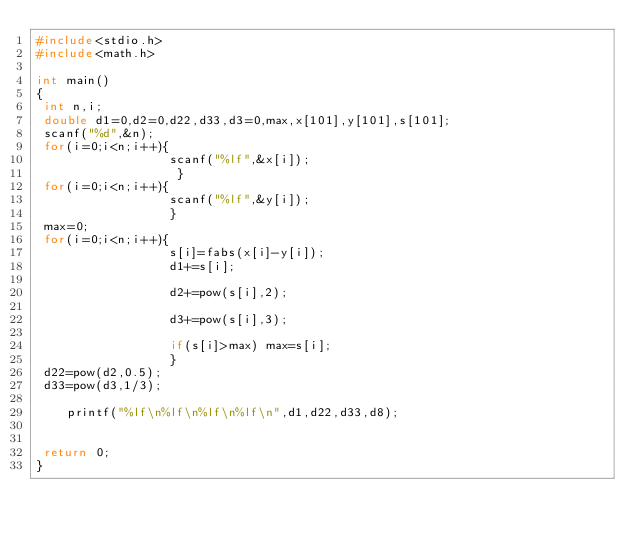<code> <loc_0><loc_0><loc_500><loc_500><_C_>#include<stdio.h>
#include<math.h>

int main()
{
 int n,i;
 double d1=0,d2=0,d22,d33,d3=0,max,x[101],y[101],s[101];
 scanf("%d",&n);
 for(i=0;i<n;i++){
                  scanf("%lf",&x[i]);
                   }
 for(i=0;i<n;i++){
                  scanf("%lf",&y[i]);
                  }
 max=0;
 for(i=0;i<n;i++){
                  s[i]=fabs(x[i]-y[i]);
                  d1+=s[i];
                  
                  d2+=pow(s[i],2);
                  
                  d3+=pow(s[i],3);
                  
                  if(s[i]>max) max=s[i];
                  } 
 d22=pow(d2,0.5);
 d33=pow(d3,1/3);

    printf("%lf\n%lf\n%lf\n%lf\n",d1,d22,d33,d8);
     

 return 0;
}

</code> 